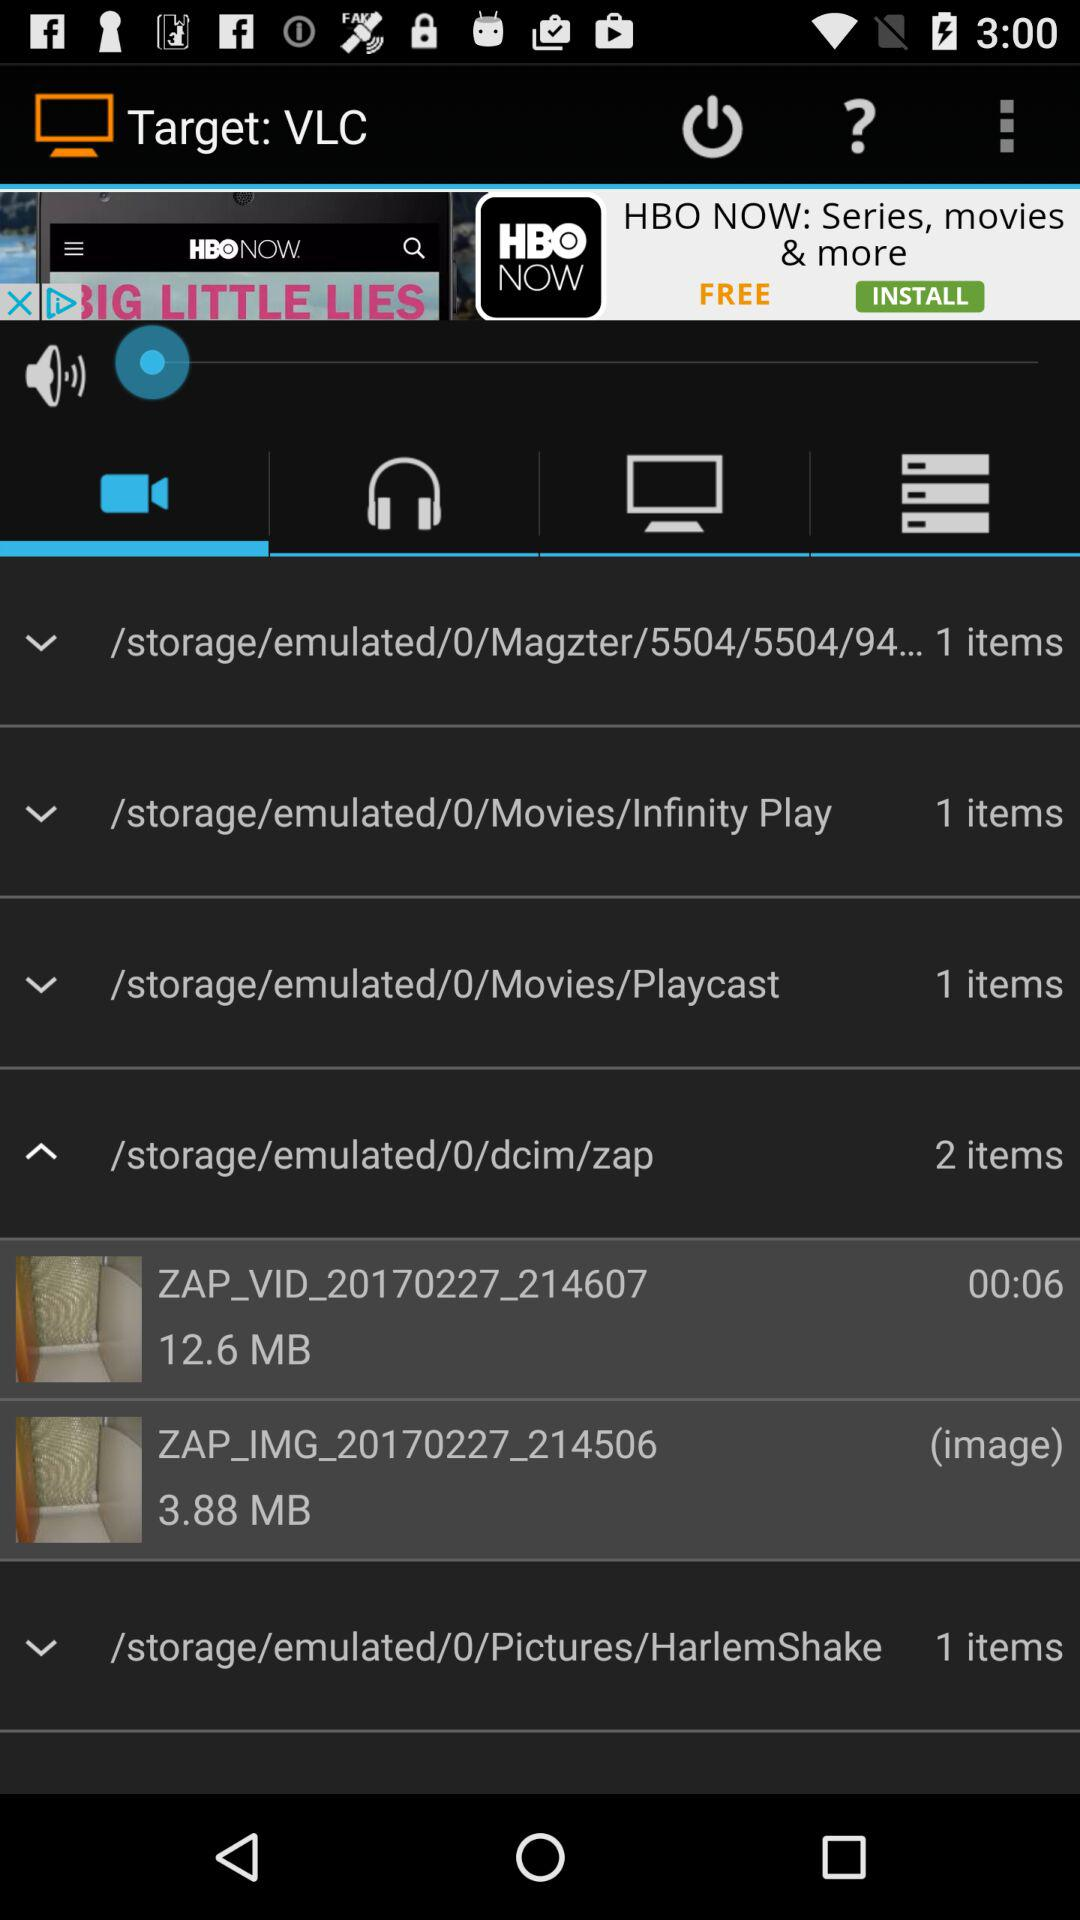What is the size of the image in the "zap" folder? The size of the image is 3.88 MB. 